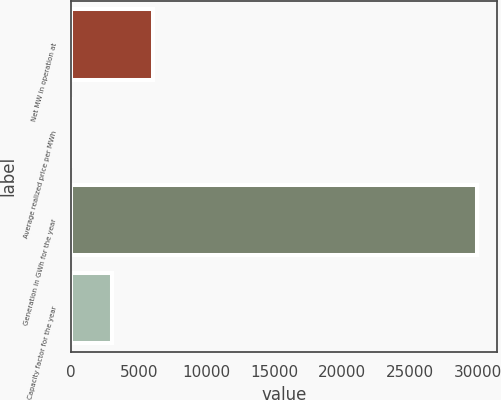<chart> <loc_0><loc_0><loc_500><loc_500><bar_chart><fcel>Net MW in operation at<fcel>Average realized price per MWh<fcel>Generation in GWh for the year<fcel>Capacity factor for the year<nl><fcel>6022.65<fcel>40.07<fcel>29953<fcel>3031.36<nl></chart> 